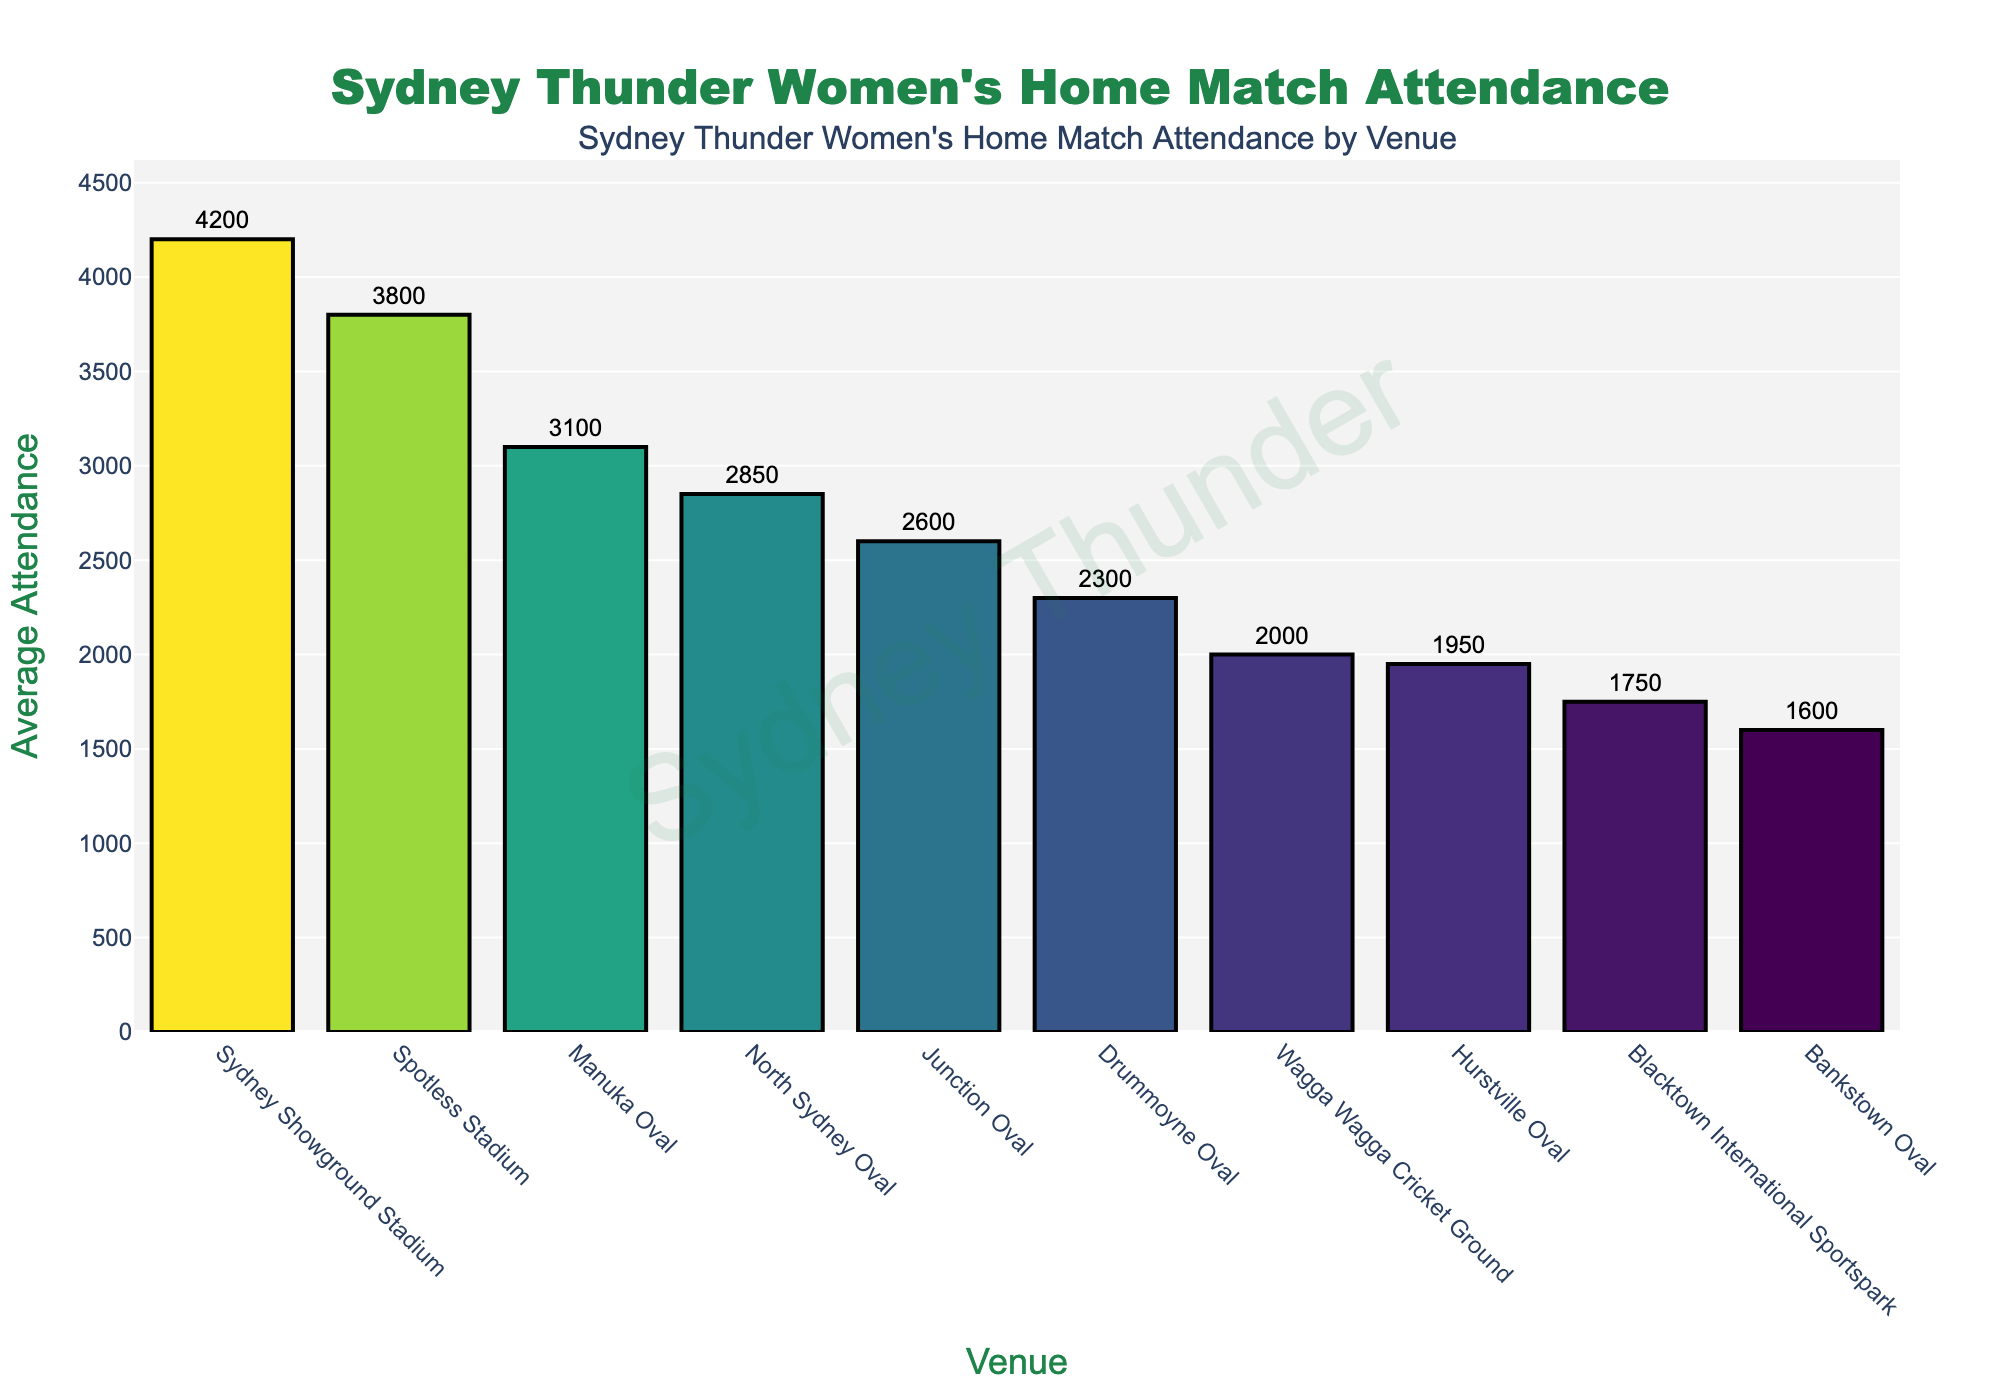Which venue has the highest average attendance? The venue with the highest bar on the figure indicates the highest average attendance. The bar representing Sydney Showground Stadium is the tallest.
Answer: Sydney Showground Stadium What is the difference in average attendance between Manuka Oval and Spotless Stadium? From the figure, Manuka Oval has an average attendance of 3100, and Spotless Stadium has 3800. The difference is calculated as 3800 - 3100.
Answer: 700 Which venue has the lowest average attendance? The venue with the shortest bar on the figure indicates the lowest average attendance. The bar representing Bankstown Oval is the shortest.
Answer: Bankstown Oval What is the average attendance across all venues? To find the average attendance, sum the attendance values for all venues and divide by the number of venues. The sum is 2850 + 1750 + 3100 + 4200 + 2300 + 1950 + 3800 + 2600 + 1600 + 2000 = 26150. There are 10 venues. The average is 26150 / 10.
Answer: 2615 Compare the average attendance between Hurstville Oval and Drummoyne Oval. Hurstville Oval has an average attendance of 1950, and Drummoyne Oval has 2300. Comparing these, 2300 is greater than 1950.
Answer: Drummoyne Oval has a higher average attendance How many venues have an average attendance of more than 3000? Identify the bars that exceed the 3000 mark. From the figure, Manuka Oval, Sydney Showground Stadium, and Spotless Stadium have attendances over 3000.
Answer: 3 What is the combined average attendance of North Sydney Oval and Blacktown International Sportspark? North Sydney Oval has 2850 and Blacktown International Sportspark has 1750. The combined average attendance is 2850 + 1750.
Answer: 4600 What percentage of the highest attendance is the lowest attendance? The highest attendance is 4200 (Sydney Showground Stadium), and the lowest is 1600 (Bankstown Oval). The percentage is calculated as (1600 / 4200) * 100.
Answer: ~38.1% Which venue has just over 2500 average attendance? From the figure, the bar for Junction Oval is slightly above 2500, specifically 2600.
Answer: Junction Oval Is the average attendance of Drummoyne Oval greater than Hurstville Oval and Wagga Wagga Cricket Ground combined? Drummoyne Oval has 2300, Hurstville Oval has 1950, and Wagga Wagga Cricket Ground has 2000. The combined attendance for the latter two is 1950 + 2000 = 3950. Compare 2300 and 3950.
Answer: No 